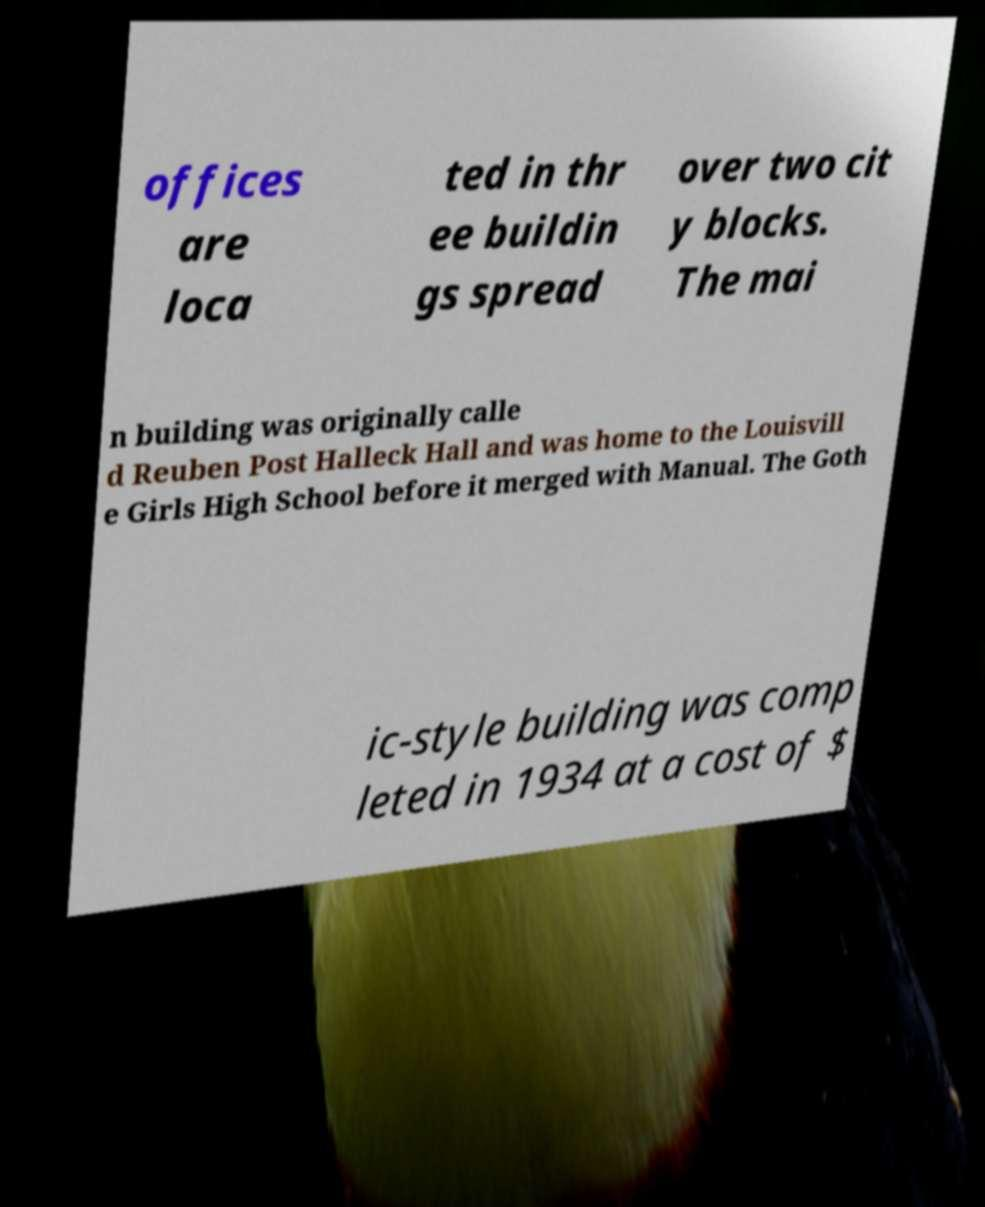Could you assist in decoding the text presented in this image and type it out clearly? offices are loca ted in thr ee buildin gs spread over two cit y blocks. The mai n building was originally calle d Reuben Post Halleck Hall and was home to the Louisvill e Girls High School before it merged with Manual. The Goth ic-style building was comp leted in 1934 at a cost of $ 